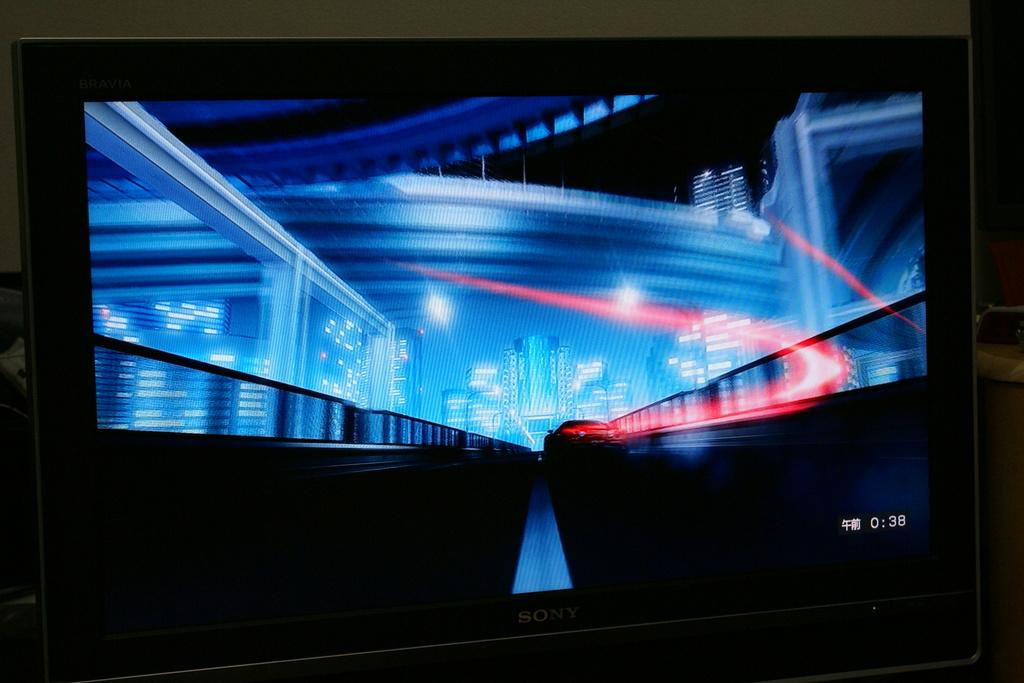<image>
Render a clear and concise summary of the photo. a screen with the numbers 38 on it 